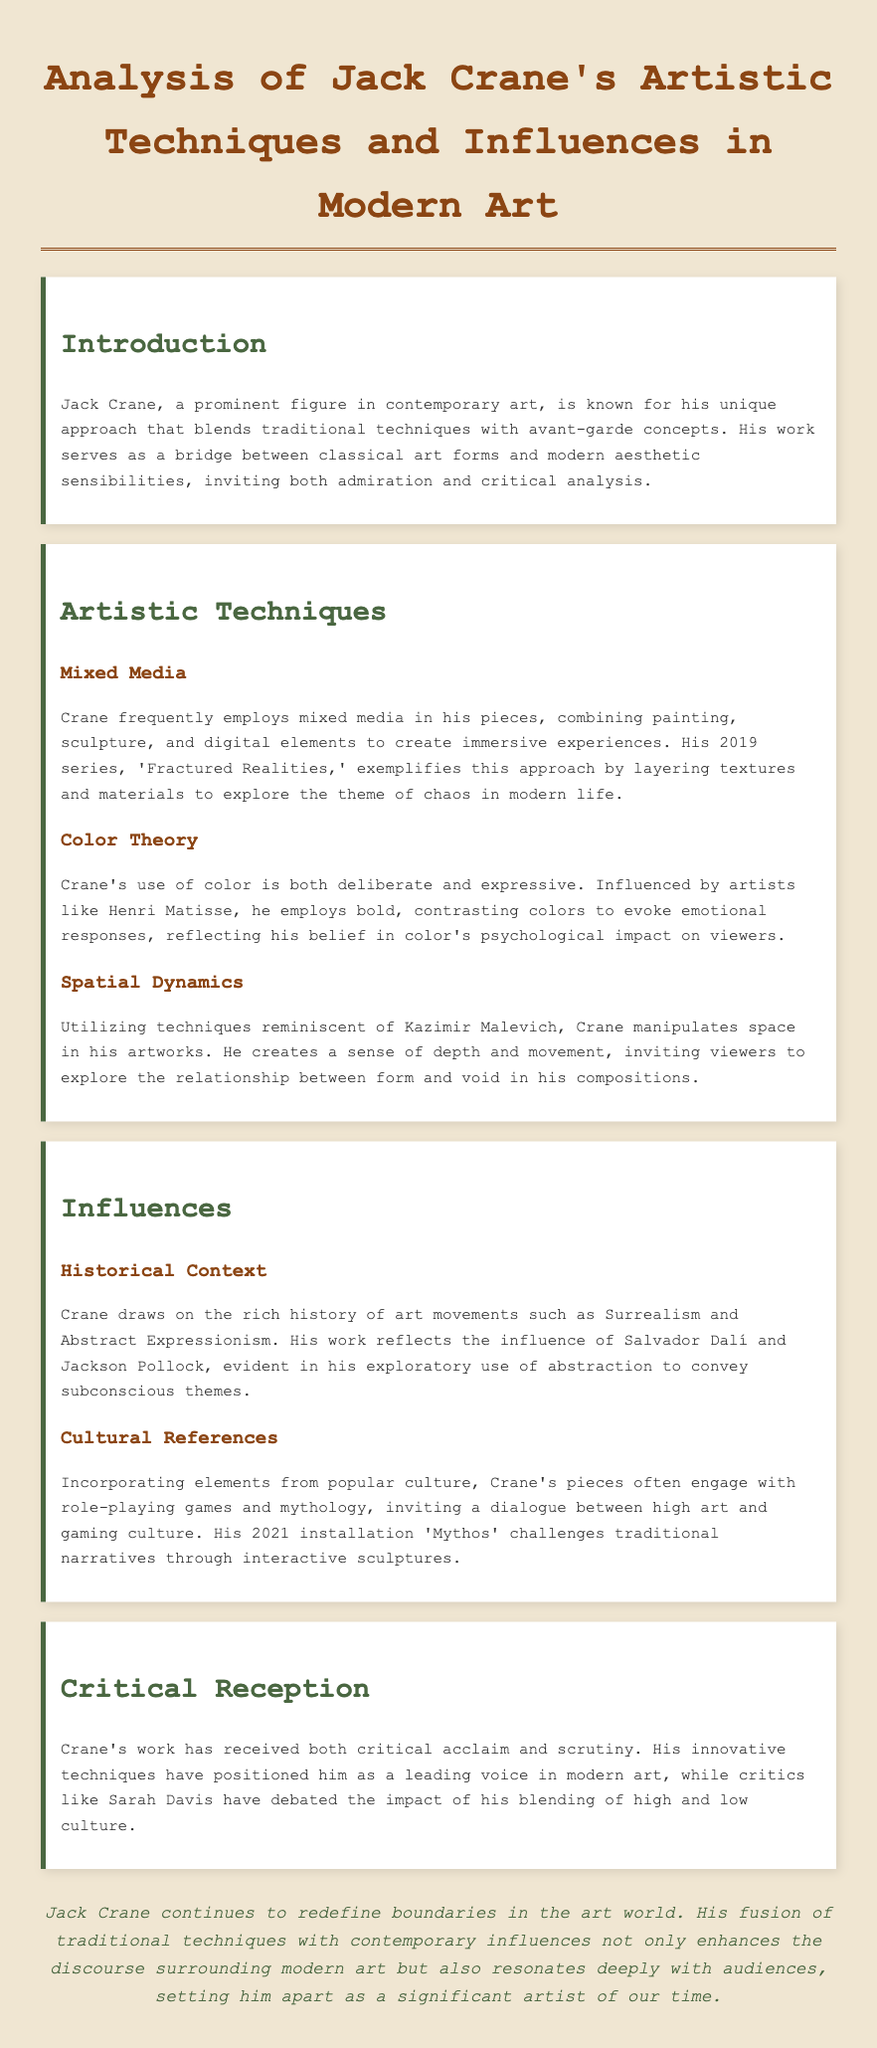what is the title of Jack Crane's 2019 series? The title is found in the section discussing his artistic techniques, specifically under mixed media.
Answer: 'Fractured Realities' who are the two artists that influenced Jack Crane's use of color? These names are mentioned in the section about color theory.
Answer: Henri Matisse what art movements does Jack Crane draw on? The document specifies these movements in the influences section.
Answer: Surrealism and Abstract Expressionism what year was Jack Crane's installation 'Mythos' created? The year of the installation is provided in the section on cultural references.
Answer: 2021 how does Jack Crane manipulate space in his artworks? This aspect is covered under spatial dynamics in the artistic techniques section.
Answer: Creates a sense of depth and movement who debated Jack Crane's blending of high and low culture? The document highlights a specific critic in the critical reception section.
Answer: Sarah Davis what aspect of modern life does Crane explore in 'Fractured Realities'? This theme is noted in the description of his mixed media technique.
Answer: Chaos which two artists are mentioned in the context of historical influences? The document lists these artists as significant influences in the influences section.
Answer: Salvador Dalí and Jackson Pollock 